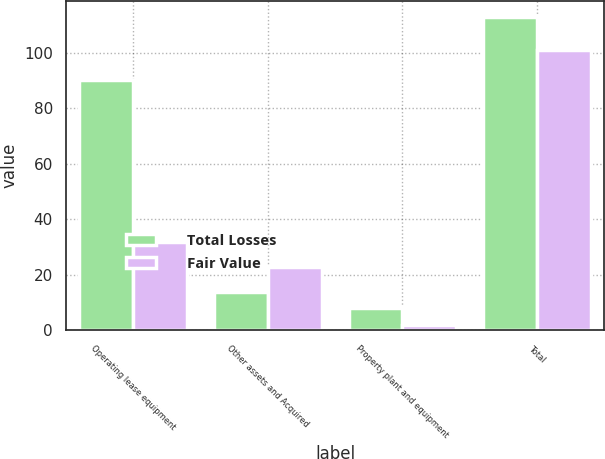Convert chart to OTSL. <chart><loc_0><loc_0><loc_500><loc_500><stacked_bar_chart><ecel><fcel>Operating lease equipment<fcel>Other assets and Acquired<fcel>Property plant and equipment<fcel>Total<nl><fcel>Total Losses<fcel>90<fcel>14<fcel>8<fcel>113<nl><fcel>Fair Value<fcel>32<fcel>23<fcel>2<fcel>101<nl></chart> 